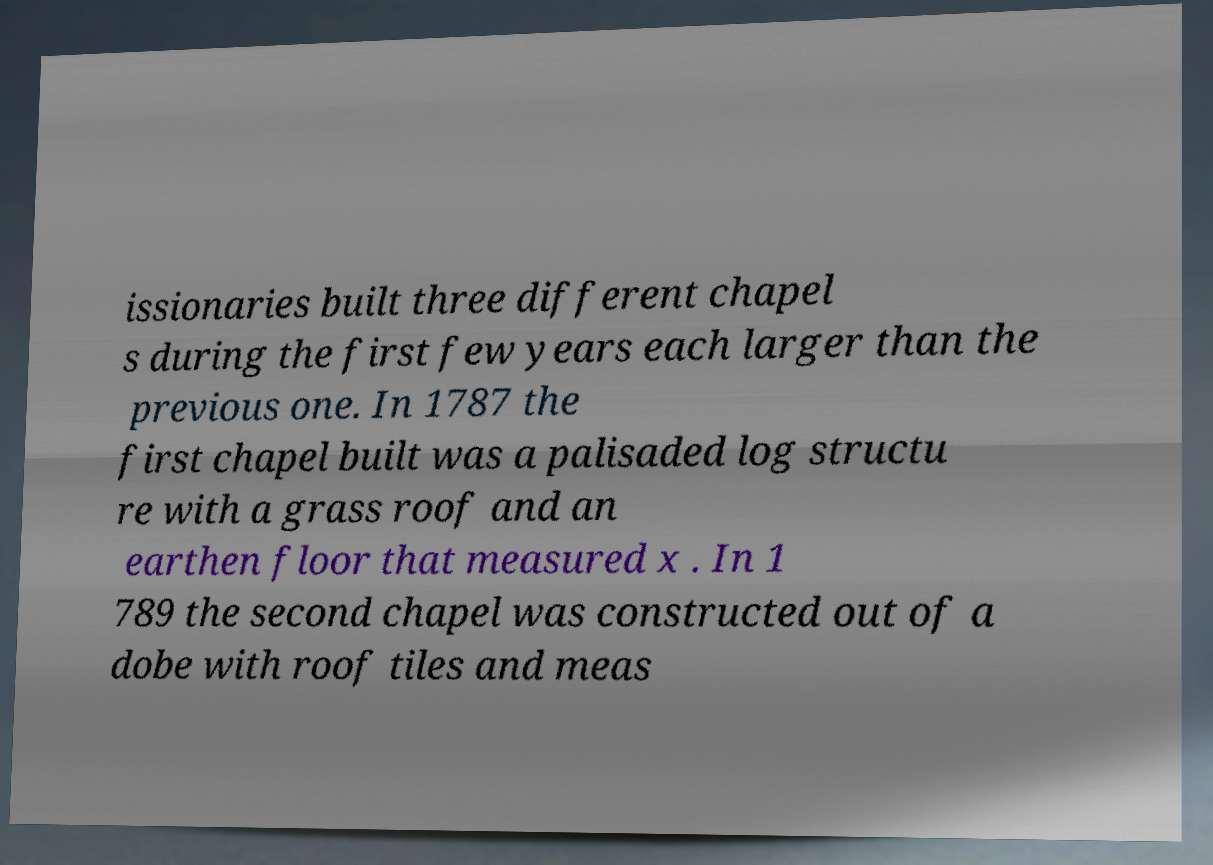Please read and relay the text visible in this image. What does it say? issionaries built three different chapel s during the first few years each larger than the previous one. In 1787 the first chapel built was a palisaded log structu re with a grass roof and an earthen floor that measured x . In 1 789 the second chapel was constructed out of a dobe with roof tiles and meas 